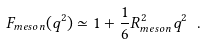Convert formula to latex. <formula><loc_0><loc_0><loc_500><loc_500>F _ { m e s o n } ( q ^ { 2 } ) \simeq 1 + \frac { 1 } { 6 } R ^ { 2 } _ { m e s o n } q ^ { 2 } \ .</formula> 